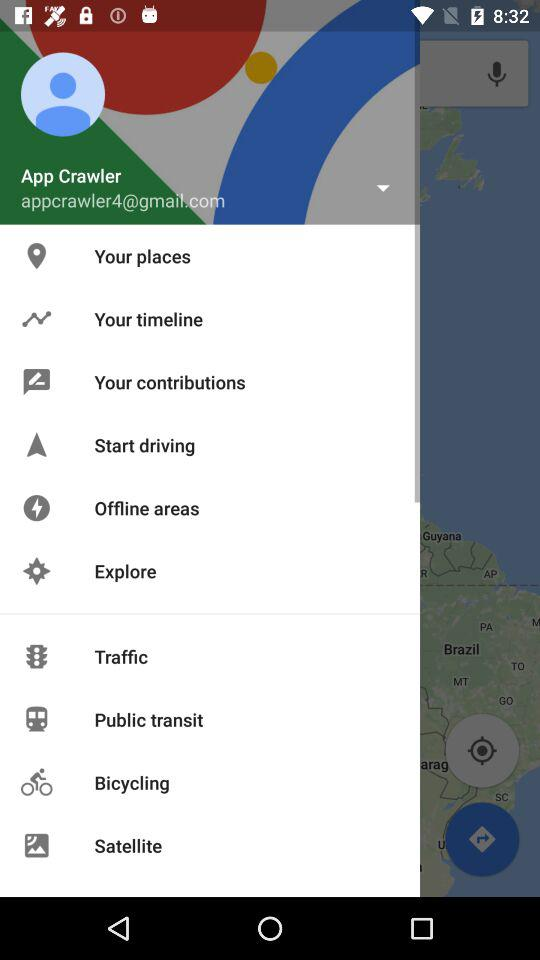What is the name of the user? The name of the user is App Crawler. 